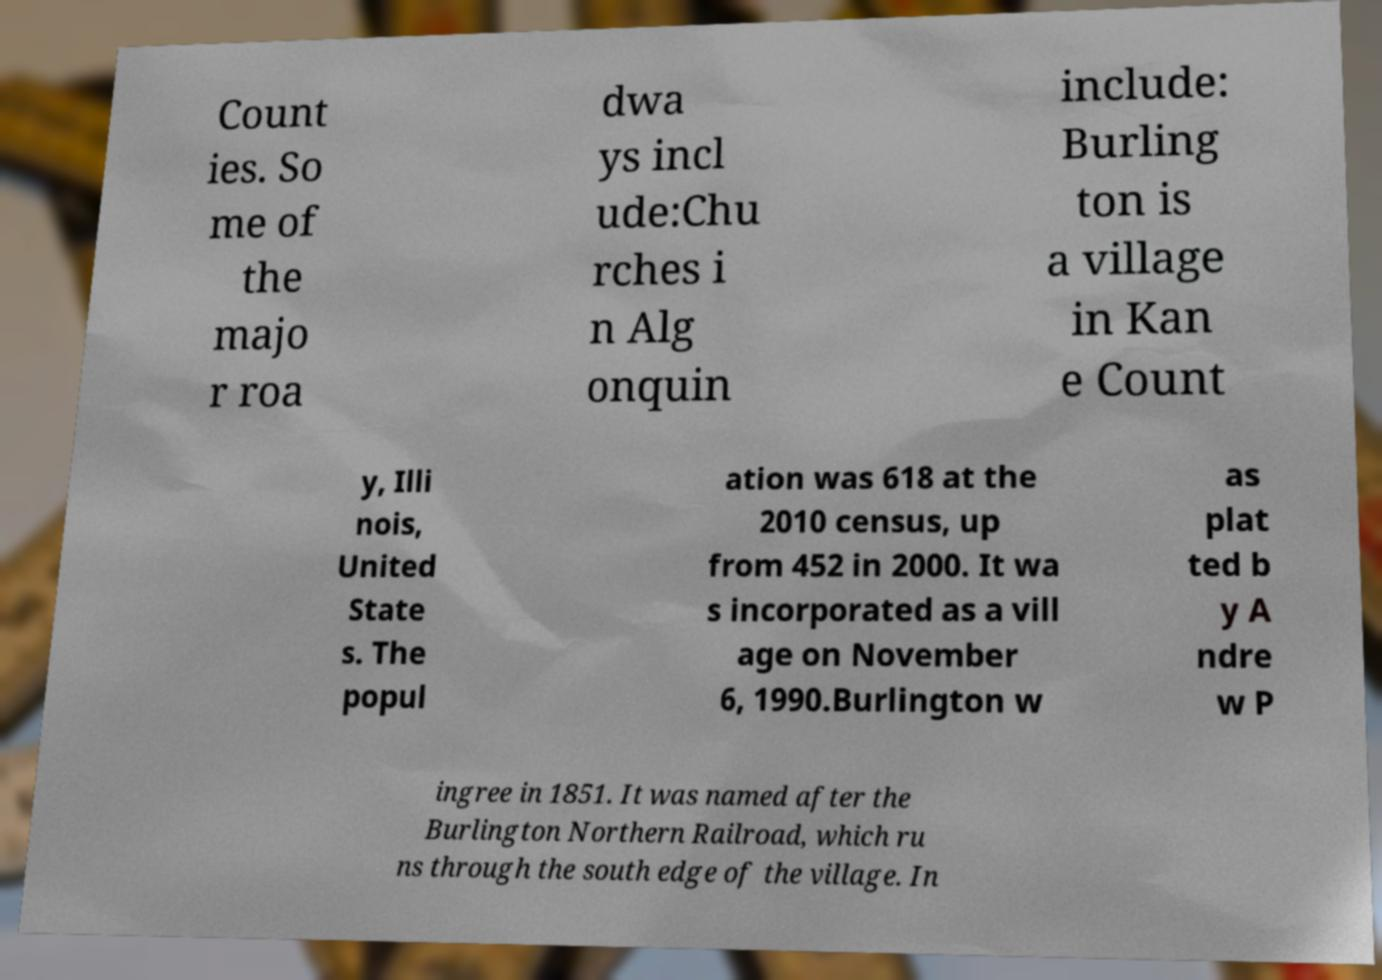There's text embedded in this image that I need extracted. Can you transcribe it verbatim? Count ies. So me of the majo r roa dwa ys incl ude:Chu rches i n Alg onquin include: Burling ton is a village in Kan e Count y, Illi nois, United State s. The popul ation was 618 at the 2010 census, up from 452 in 2000. It wa s incorporated as a vill age on November 6, 1990.Burlington w as plat ted b y A ndre w P ingree in 1851. It was named after the Burlington Northern Railroad, which ru ns through the south edge of the village. In 